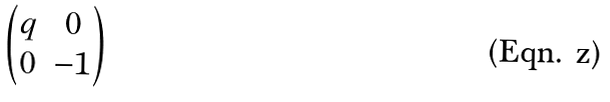<formula> <loc_0><loc_0><loc_500><loc_500>\begin{pmatrix} q & 0 \\ 0 & - 1 \end{pmatrix}</formula> 